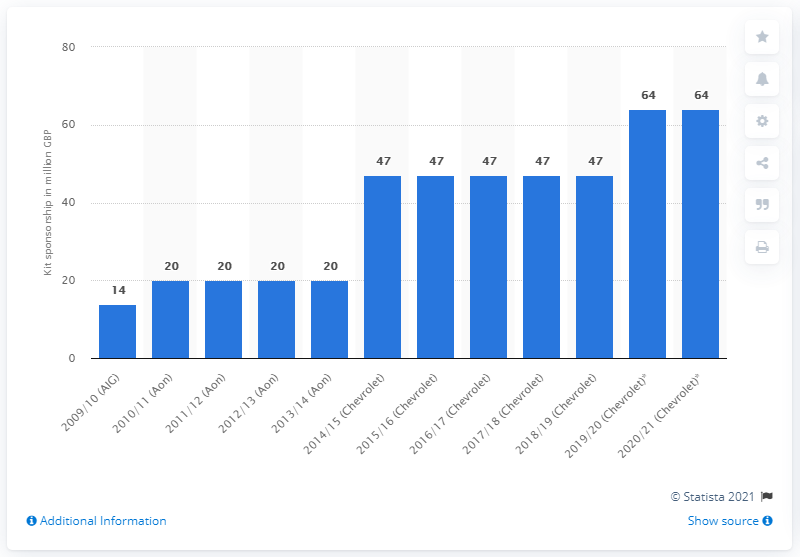Highlight a few significant elements in this photo. In the 2020/2021 season, Manchester United received £64 million from Chevrolet, a significant sum that contributed to the club's overall revenue. 